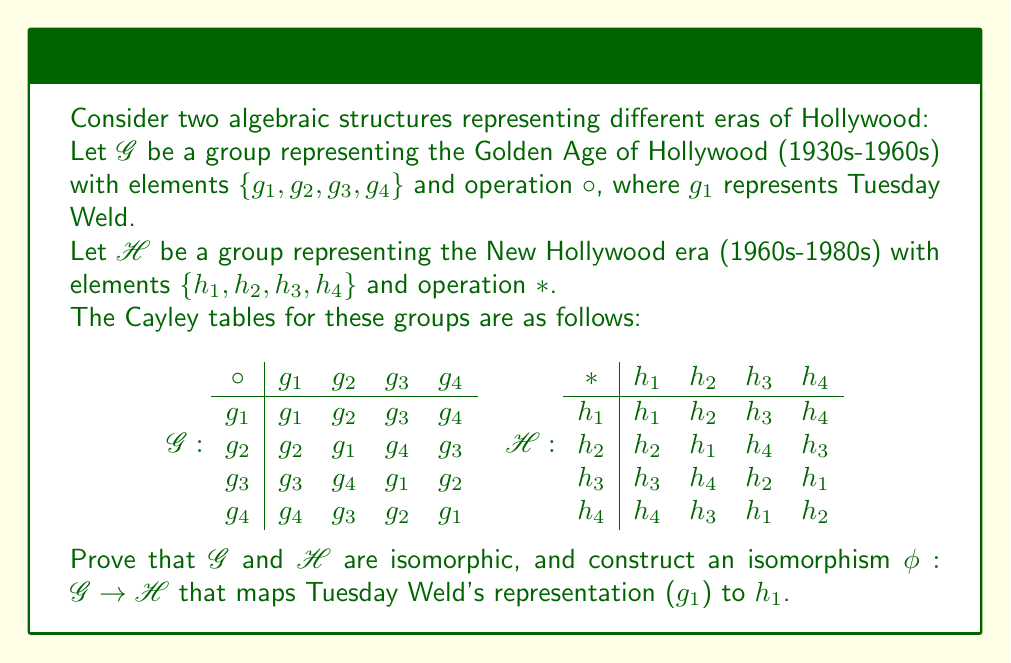Provide a solution to this math problem. To prove that $G$ and $H$ are isomorphic and construct the required isomorphism, we'll follow these steps:

1) First, we need to verify that both $G$ and $H$ are indeed groups. From the Cayley tables, we can see that both satisfy the group axioms: closure, associativity, identity element (g_1 and h_1), and inverse elements for each element.

2) To prove isomorphism, we need to find a bijective homomorphism $\phi: G \to H$. Given the requirement that $\phi(g_1) = h_1$, we can start constructing our mapping:

   $\phi(g_1) = h_1$

3) Now, let's examine the structure of these groups. We can see that both $G$ and $H$ have the following properties:
   - They are of order 4
   - They have one element of order 1 (the identity)
   - They have three elements of order 2

   This structure is consistent with the Klein four-group, $V_4$.

4) To complete our isomorphism, we need to map the remaining elements while preserving the group structure. Let's map:

   $\phi(g_2) = h_2$
   $\phi(g_3) = h_3$
   $\phi(g_4) = h_4$

5) Now we need to verify that this mapping preserves the group operation. Let's check a few examples:

   $\phi(g_2 \circ g_3) = \phi(g_4) = h_4$
   $\phi(g_2) * \phi(g_3) = h_2 * h_3 = h_4$

   $\phi(g_3 \circ g_4) = \phi(g_2) = h_2$
   $\phi(g_3) * \phi(g_4) = h_3 * h_4 = h_2$

6) We can see that the mapping preserves the group operation for all combinations of elements (you can verify the rest).

7) Our mapping $\phi$ is bijective as it's a one-to-one correspondence between the elements of $G$ and $H$.

Therefore, $\phi$ is an isomorphism between $G$ and $H$, proving that the two groups are isomorphic.

This isomorphism demonstrates that the algebraic structure representing the Golden Age of Hollywood (with Tuesday Weld as a key element) is fundamentally the same as the structure representing the New Hollywood era, despite the surface-level differences between these periods in film history.
Answer: The groups $G$ and $H$ are isomorphic. An isomorphism $\phi: G \to H$ that maps Tuesday Weld's representation ($g_1$) to $h_1$ is given by:

$\phi(g_1) = h_1$
$\phi(g_2) = h_2$
$\phi(g_3) = h_3$
$\phi(g_4) = h_4$

This mapping is a bijective homomorphism that preserves the group structure, thus proving the isomorphism between $G$ and $H$. 